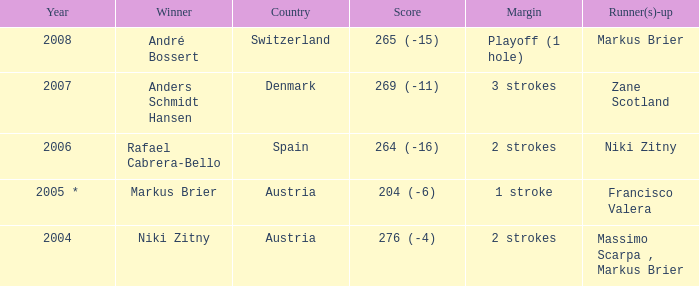Who was the runner-up when the year was 2008? Markus Brier. 